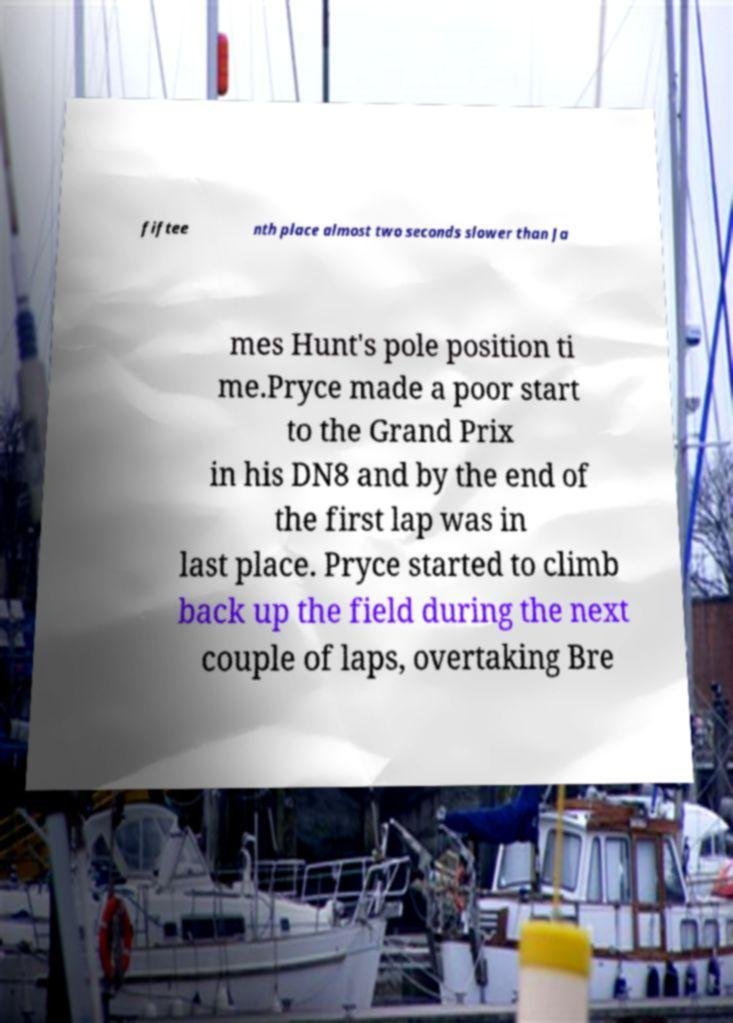What messages or text are displayed in this image? I need them in a readable, typed format. fiftee nth place almost two seconds slower than Ja mes Hunt's pole position ti me.Pryce made a poor start to the Grand Prix in his DN8 and by the end of the first lap was in last place. Pryce started to climb back up the field during the next couple of laps, overtaking Bre 